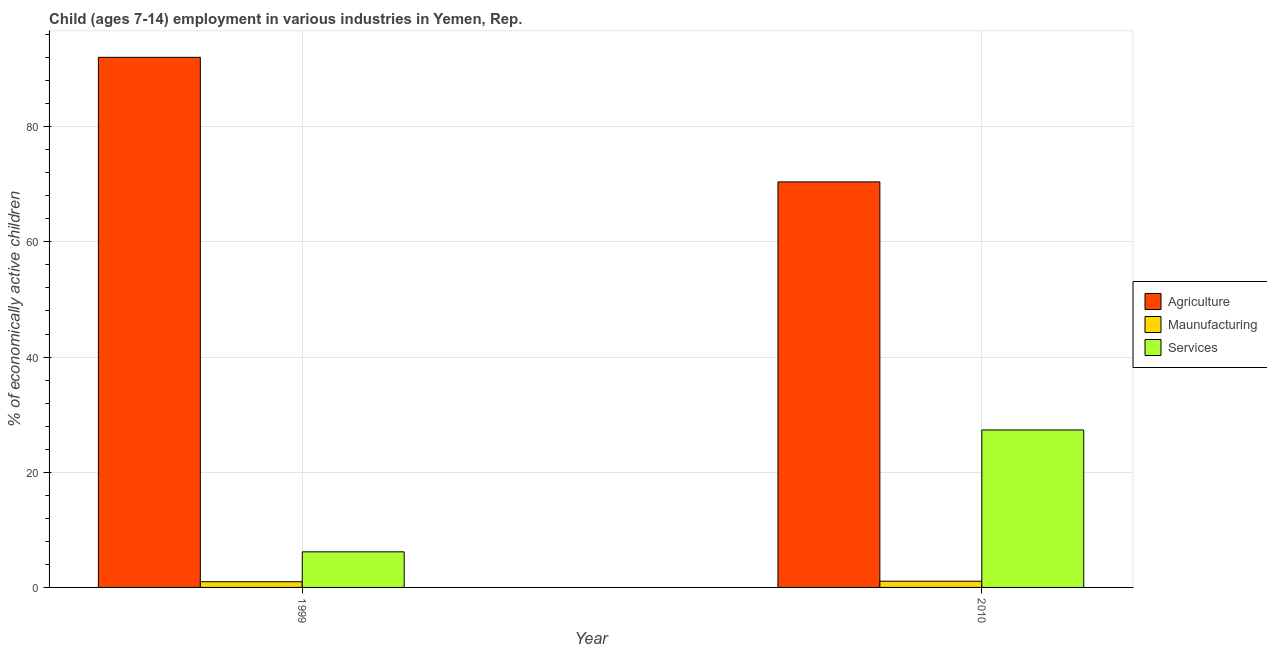How many different coloured bars are there?
Ensure brevity in your answer.  3. How many groups of bars are there?
Give a very brief answer. 2. Are the number of bars on each tick of the X-axis equal?
Make the answer very short. Yes. How many bars are there on the 1st tick from the left?
Make the answer very short. 3. What is the label of the 1st group of bars from the left?
Keep it short and to the point. 1999. In how many cases, is the number of bars for a given year not equal to the number of legend labels?
Provide a succinct answer. 0. What is the percentage of economically active children in agriculture in 1999?
Your answer should be very brief. 92.04. Across all years, what is the maximum percentage of economically active children in manufacturing?
Provide a succinct answer. 1.08. Across all years, what is the minimum percentage of economically active children in manufacturing?
Offer a very short reply. 0.99. In which year was the percentage of economically active children in services minimum?
Ensure brevity in your answer.  1999. What is the total percentage of economically active children in manufacturing in the graph?
Your answer should be very brief. 2.07. What is the difference between the percentage of economically active children in agriculture in 1999 and that in 2010?
Provide a succinct answer. 21.63. What is the difference between the percentage of economically active children in manufacturing in 2010 and the percentage of economically active children in services in 1999?
Give a very brief answer. 0.09. What is the average percentage of economically active children in manufacturing per year?
Your answer should be compact. 1.04. In how many years, is the percentage of economically active children in services greater than 68 %?
Ensure brevity in your answer.  0. What is the ratio of the percentage of economically active children in services in 1999 to that in 2010?
Offer a terse response. 0.23. What does the 1st bar from the left in 1999 represents?
Provide a succinct answer. Agriculture. What does the 1st bar from the right in 1999 represents?
Your response must be concise. Services. Is it the case that in every year, the sum of the percentage of economically active children in agriculture and percentage of economically active children in manufacturing is greater than the percentage of economically active children in services?
Give a very brief answer. Yes. How many bars are there?
Keep it short and to the point. 6. Does the graph contain grids?
Provide a succinct answer. Yes. How are the legend labels stacked?
Ensure brevity in your answer.  Vertical. What is the title of the graph?
Your response must be concise. Child (ages 7-14) employment in various industries in Yemen, Rep. What is the label or title of the Y-axis?
Offer a terse response. % of economically active children. What is the % of economically active children of Agriculture in 1999?
Provide a short and direct response. 92.04. What is the % of economically active children in Services in 1999?
Offer a very short reply. 6.18. What is the % of economically active children in Agriculture in 2010?
Your response must be concise. 70.41. What is the % of economically active children in Services in 2010?
Make the answer very short. 27.34. Across all years, what is the maximum % of economically active children in Agriculture?
Your answer should be compact. 92.04. Across all years, what is the maximum % of economically active children of Services?
Provide a succinct answer. 27.34. Across all years, what is the minimum % of economically active children in Agriculture?
Give a very brief answer. 70.41. Across all years, what is the minimum % of economically active children of Services?
Ensure brevity in your answer.  6.18. What is the total % of economically active children in Agriculture in the graph?
Your answer should be compact. 162.45. What is the total % of economically active children of Maunufacturing in the graph?
Provide a succinct answer. 2.07. What is the total % of economically active children in Services in the graph?
Your answer should be compact. 33.52. What is the difference between the % of economically active children of Agriculture in 1999 and that in 2010?
Give a very brief answer. 21.63. What is the difference between the % of economically active children of Maunufacturing in 1999 and that in 2010?
Keep it short and to the point. -0.09. What is the difference between the % of economically active children in Services in 1999 and that in 2010?
Your answer should be very brief. -21.16. What is the difference between the % of economically active children in Agriculture in 1999 and the % of economically active children in Maunufacturing in 2010?
Make the answer very short. 90.96. What is the difference between the % of economically active children of Agriculture in 1999 and the % of economically active children of Services in 2010?
Provide a succinct answer. 64.7. What is the difference between the % of economically active children of Maunufacturing in 1999 and the % of economically active children of Services in 2010?
Keep it short and to the point. -26.35. What is the average % of economically active children of Agriculture per year?
Keep it short and to the point. 81.22. What is the average % of economically active children in Maunufacturing per year?
Keep it short and to the point. 1.03. What is the average % of economically active children in Services per year?
Make the answer very short. 16.76. In the year 1999, what is the difference between the % of economically active children of Agriculture and % of economically active children of Maunufacturing?
Your response must be concise. 91.05. In the year 1999, what is the difference between the % of economically active children in Agriculture and % of economically active children in Services?
Keep it short and to the point. 85.86. In the year 1999, what is the difference between the % of economically active children of Maunufacturing and % of economically active children of Services?
Ensure brevity in your answer.  -5.19. In the year 2010, what is the difference between the % of economically active children in Agriculture and % of economically active children in Maunufacturing?
Provide a succinct answer. 69.33. In the year 2010, what is the difference between the % of economically active children of Agriculture and % of economically active children of Services?
Give a very brief answer. 43.07. In the year 2010, what is the difference between the % of economically active children in Maunufacturing and % of economically active children in Services?
Keep it short and to the point. -26.26. What is the ratio of the % of economically active children in Agriculture in 1999 to that in 2010?
Offer a terse response. 1.31. What is the ratio of the % of economically active children of Maunufacturing in 1999 to that in 2010?
Offer a terse response. 0.92. What is the ratio of the % of economically active children of Services in 1999 to that in 2010?
Your answer should be compact. 0.23. What is the difference between the highest and the second highest % of economically active children in Agriculture?
Offer a terse response. 21.63. What is the difference between the highest and the second highest % of economically active children of Maunufacturing?
Provide a short and direct response. 0.09. What is the difference between the highest and the second highest % of economically active children of Services?
Ensure brevity in your answer.  21.16. What is the difference between the highest and the lowest % of economically active children of Agriculture?
Make the answer very short. 21.63. What is the difference between the highest and the lowest % of economically active children of Maunufacturing?
Your answer should be compact. 0.09. What is the difference between the highest and the lowest % of economically active children of Services?
Give a very brief answer. 21.16. 